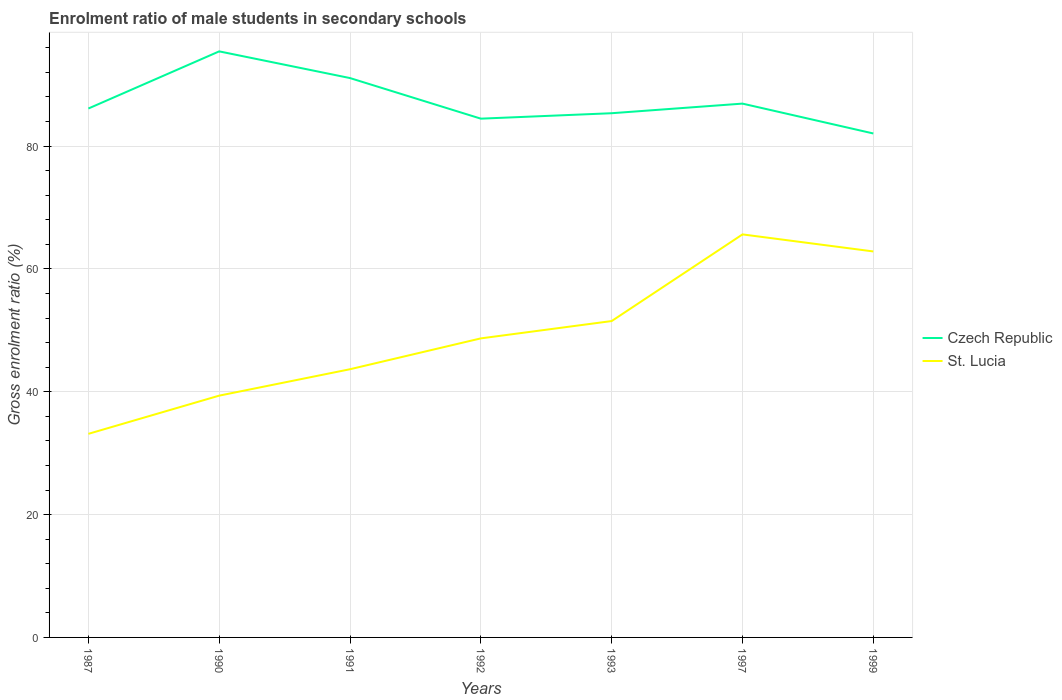How many different coloured lines are there?
Provide a short and direct response. 2. Does the line corresponding to St. Lucia intersect with the line corresponding to Czech Republic?
Provide a succinct answer. No. Across all years, what is the maximum enrolment ratio of male students in secondary schools in St. Lucia?
Provide a succinct answer. 33.15. What is the total enrolment ratio of male students in secondary schools in St. Lucia in the graph?
Give a very brief answer. -2.82. What is the difference between the highest and the second highest enrolment ratio of male students in secondary schools in St. Lucia?
Your answer should be compact. 32.47. Is the enrolment ratio of male students in secondary schools in Czech Republic strictly greater than the enrolment ratio of male students in secondary schools in St. Lucia over the years?
Make the answer very short. No. What is the difference between two consecutive major ticks on the Y-axis?
Provide a short and direct response. 20. Does the graph contain any zero values?
Give a very brief answer. No. Does the graph contain grids?
Keep it short and to the point. Yes. Where does the legend appear in the graph?
Your answer should be compact. Center right. How are the legend labels stacked?
Offer a terse response. Vertical. What is the title of the graph?
Keep it short and to the point. Enrolment ratio of male students in secondary schools. Does "Heavily indebted poor countries" appear as one of the legend labels in the graph?
Offer a terse response. No. What is the Gross enrolment ratio (%) in Czech Republic in 1987?
Keep it short and to the point. 86.12. What is the Gross enrolment ratio (%) of St. Lucia in 1987?
Your response must be concise. 33.15. What is the Gross enrolment ratio (%) of Czech Republic in 1990?
Ensure brevity in your answer.  95.42. What is the Gross enrolment ratio (%) of St. Lucia in 1990?
Offer a terse response. 39.37. What is the Gross enrolment ratio (%) in Czech Republic in 1991?
Provide a short and direct response. 91.08. What is the Gross enrolment ratio (%) of St. Lucia in 1991?
Provide a succinct answer. 43.67. What is the Gross enrolment ratio (%) in Czech Republic in 1992?
Ensure brevity in your answer.  84.47. What is the Gross enrolment ratio (%) in St. Lucia in 1992?
Keep it short and to the point. 48.69. What is the Gross enrolment ratio (%) of Czech Republic in 1993?
Offer a terse response. 85.35. What is the Gross enrolment ratio (%) in St. Lucia in 1993?
Keep it short and to the point. 51.51. What is the Gross enrolment ratio (%) of Czech Republic in 1997?
Offer a terse response. 86.92. What is the Gross enrolment ratio (%) in St. Lucia in 1997?
Offer a very short reply. 65.62. What is the Gross enrolment ratio (%) of Czech Republic in 1999?
Ensure brevity in your answer.  82.05. What is the Gross enrolment ratio (%) of St. Lucia in 1999?
Your answer should be very brief. 62.85. Across all years, what is the maximum Gross enrolment ratio (%) in Czech Republic?
Ensure brevity in your answer.  95.42. Across all years, what is the maximum Gross enrolment ratio (%) in St. Lucia?
Your answer should be compact. 65.62. Across all years, what is the minimum Gross enrolment ratio (%) in Czech Republic?
Provide a short and direct response. 82.05. Across all years, what is the minimum Gross enrolment ratio (%) of St. Lucia?
Provide a succinct answer. 33.15. What is the total Gross enrolment ratio (%) in Czech Republic in the graph?
Your response must be concise. 611.41. What is the total Gross enrolment ratio (%) in St. Lucia in the graph?
Offer a terse response. 344.86. What is the difference between the Gross enrolment ratio (%) in Czech Republic in 1987 and that in 1990?
Ensure brevity in your answer.  -9.31. What is the difference between the Gross enrolment ratio (%) in St. Lucia in 1987 and that in 1990?
Ensure brevity in your answer.  -6.22. What is the difference between the Gross enrolment ratio (%) of Czech Republic in 1987 and that in 1991?
Ensure brevity in your answer.  -4.96. What is the difference between the Gross enrolment ratio (%) in St. Lucia in 1987 and that in 1991?
Your answer should be very brief. -10.52. What is the difference between the Gross enrolment ratio (%) in Czech Republic in 1987 and that in 1992?
Ensure brevity in your answer.  1.65. What is the difference between the Gross enrolment ratio (%) in St. Lucia in 1987 and that in 1992?
Provide a succinct answer. -15.54. What is the difference between the Gross enrolment ratio (%) in Czech Republic in 1987 and that in 1993?
Give a very brief answer. 0.76. What is the difference between the Gross enrolment ratio (%) in St. Lucia in 1987 and that in 1993?
Your answer should be compact. -18.37. What is the difference between the Gross enrolment ratio (%) in Czech Republic in 1987 and that in 1997?
Provide a succinct answer. -0.8. What is the difference between the Gross enrolment ratio (%) in St. Lucia in 1987 and that in 1997?
Ensure brevity in your answer.  -32.47. What is the difference between the Gross enrolment ratio (%) of Czech Republic in 1987 and that in 1999?
Offer a very short reply. 4.06. What is the difference between the Gross enrolment ratio (%) of St. Lucia in 1987 and that in 1999?
Provide a short and direct response. -29.7. What is the difference between the Gross enrolment ratio (%) of Czech Republic in 1990 and that in 1991?
Offer a very short reply. 4.35. What is the difference between the Gross enrolment ratio (%) of St. Lucia in 1990 and that in 1991?
Your answer should be compact. -4.3. What is the difference between the Gross enrolment ratio (%) of Czech Republic in 1990 and that in 1992?
Give a very brief answer. 10.96. What is the difference between the Gross enrolment ratio (%) of St. Lucia in 1990 and that in 1992?
Provide a short and direct response. -9.32. What is the difference between the Gross enrolment ratio (%) in Czech Republic in 1990 and that in 1993?
Your response must be concise. 10.07. What is the difference between the Gross enrolment ratio (%) of St. Lucia in 1990 and that in 1993?
Give a very brief answer. -12.14. What is the difference between the Gross enrolment ratio (%) in Czech Republic in 1990 and that in 1997?
Give a very brief answer. 8.51. What is the difference between the Gross enrolment ratio (%) of St. Lucia in 1990 and that in 1997?
Your answer should be compact. -26.25. What is the difference between the Gross enrolment ratio (%) of Czech Republic in 1990 and that in 1999?
Your answer should be compact. 13.37. What is the difference between the Gross enrolment ratio (%) of St. Lucia in 1990 and that in 1999?
Provide a short and direct response. -23.48. What is the difference between the Gross enrolment ratio (%) in Czech Republic in 1991 and that in 1992?
Offer a terse response. 6.61. What is the difference between the Gross enrolment ratio (%) of St. Lucia in 1991 and that in 1992?
Provide a succinct answer. -5.02. What is the difference between the Gross enrolment ratio (%) of Czech Republic in 1991 and that in 1993?
Provide a short and direct response. 5.72. What is the difference between the Gross enrolment ratio (%) in St. Lucia in 1991 and that in 1993?
Offer a very short reply. -7.84. What is the difference between the Gross enrolment ratio (%) in Czech Republic in 1991 and that in 1997?
Provide a succinct answer. 4.16. What is the difference between the Gross enrolment ratio (%) in St. Lucia in 1991 and that in 1997?
Your answer should be very brief. -21.95. What is the difference between the Gross enrolment ratio (%) in Czech Republic in 1991 and that in 1999?
Your answer should be compact. 9.02. What is the difference between the Gross enrolment ratio (%) of St. Lucia in 1991 and that in 1999?
Your answer should be compact. -19.18. What is the difference between the Gross enrolment ratio (%) in Czech Republic in 1992 and that in 1993?
Your response must be concise. -0.89. What is the difference between the Gross enrolment ratio (%) of St. Lucia in 1992 and that in 1993?
Make the answer very short. -2.82. What is the difference between the Gross enrolment ratio (%) of Czech Republic in 1992 and that in 1997?
Give a very brief answer. -2.45. What is the difference between the Gross enrolment ratio (%) of St. Lucia in 1992 and that in 1997?
Ensure brevity in your answer.  -16.93. What is the difference between the Gross enrolment ratio (%) of Czech Republic in 1992 and that in 1999?
Offer a very short reply. 2.41. What is the difference between the Gross enrolment ratio (%) in St. Lucia in 1992 and that in 1999?
Keep it short and to the point. -14.15. What is the difference between the Gross enrolment ratio (%) in Czech Republic in 1993 and that in 1997?
Offer a very short reply. -1.56. What is the difference between the Gross enrolment ratio (%) in St. Lucia in 1993 and that in 1997?
Your response must be concise. -14.11. What is the difference between the Gross enrolment ratio (%) of Czech Republic in 1993 and that in 1999?
Offer a terse response. 3.3. What is the difference between the Gross enrolment ratio (%) of St. Lucia in 1993 and that in 1999?
Keep it short and to the point. -11.33. What is the difference between the Gross enrolment ratio (%) of Czech Republic in 1997 and that in 1999?
Your answer should be very brief. 4.86. What is the difference between the Gross enrolment ratio (%) in St. Lucia in 1997 and that in 1999?
Your response must be concise. 2.77. What is the difference between the Gross enrolment ratio (%) in Czech Republic in 1987 and the Gross enrolment ratio (%) in St. Lucia in 1990?
Provide a short and direct response. 46.75. What is the difference between the Gross enrolment ratio (%) of Czech Republic in 1987 and the Gross enrolment ratio (%) of St. Lucia in 1991?
Your response must be concise. 42.45. What is the difference between the Gross enrolment ratio (%) in Czech Republic in 1987 and the Gross enrolment ratio (%) in St. Lucia in 1992?
Your answer should be very brief. 37.43. What is the difference between the Gross enrolment ratio (%) in Czech Republic in 1987 and the Gross enrolment ratio (%) in St. Lucia in 1993?
Provide a succinct answer. 34.6. What is the difference between the Gross enrolment ratio (%) of Czech Republic in 1987 and the Gross enrolment ratio (%) of St. Lucia in 1997?
Keep it short and to the point. 20.5. What is the difference between the Gross enrolment ratio (%) in Czech Republic in 1987 and the Gross enrolment ratio (%) in St. Lucia in 1999?
Offer a terse response. 23.27. What is the difference between the Gross enrolment ratio (%) in Czech Republic in 1990 and the Gross enrolment ratio (%) in St. Lucia in 1991?
Ensure brevity in your answer.  51.75. What is the difference between the Gross enrolment ratio (%) of Czech Republic in 1990 and the Gross enrolment ratio (%) of St. Lucia in 1992?
Offer a very short reply. 46.73. What is the difference between the Gross enrolment ratio (%) in Czech Republic in 1990 and the Gross enrolment ratio (%) in St. Lucia in 1993?
Make the answer very short. 43.91. What is the difference between the Gross enrolment ratio (%) in Czech Republic in 1990 and the Gross enrolment ratio (%) in St. Lucia in 1997?
Your response must be concise. 29.8. What is the difference between the Gross enrolment ratio (%) in Czech Republic in 1990 and the Gross enrolment ratio (%) in St. Lucia in 1999?
Offer a terse response. 32.58. What is the difference between the Gross enrolment ratio (%) of Czech Republic in 1991 and the Gross enrolment ratio (%) of St. Lucia in 1992?
Ensure brevity in your answer.  42.38. What is the difference between the Gross enrolment ratio (%) of Czech Republic in 1991 and the Gross enrolment ratio (%) of St. Lucia in 1993?
Provide a succinct answer. 39.56. What is the difference between the Gross enrolment ratio (%) of Czech Republic in 1991 and the Gross enrolment ratio (%) of St. Lucia in 1997?
Give a very brief answer. 25.45. What is the difference between the Gross enrolment ratio (%) of Czech Republic in 1991 and the Gross enrolment ratio (%) of St. Lucia in 1999?
Your answer should be very brief. 28.23. What is the difference between the Gross enrolment ratio (%) of Czech Republic in 1992 and the Gross enrolment ratio (%) of St. Lucia in 1993?
Offer a terse response. 32.95. What is the difference between the Gross enrolment ratio (%) in Czech Republic in 1992 and the Gross enrolment ratio (%) in St. Lucia in 1997?
Your answer should be compact. 18.85. What is the difference between the Gross enrolment ratio (%) of Czech Republic in 1992 and the Gross enrolment ratio (%) of St. Lucia in 1999?
Provide a short and direct response. 21.62. What is the difference between the Gross enrolment ratio (%) of Czech Republic in 1993 and the Gross enrolment ratio (%) of St. Lucia in 1997?
Your answer should be very brief. 19.73. What is the difference between the Gross enrolment ratio (%) in Czech Republic in 1993 and the Gross enrolment ratio (%) in St. Lucia in 1999?
Your response must be concise. 22.51. What is the difference between the Gross enrolment ratio (%) of Czech Republic in 1997 and the Gross enrolment ratio (%) of St. Lucia in 1999?
Keep it short and to the point. 24.07. What is the average Gross enrolment ratio (%) in Czech Republic per year?
Provide a succinct answer. 87.34. What is the average Gross enrolment ratio (%) in St. Lucia per year?
Offer a very short reply. 49.27. In the year 1987, what is the difference between the Gross enrolment ratio (%) in Czech Republic and Gross enrolment ratio (%) in St. Lucia?
Ensure brevity in your answer.  52.97. In the year 1990, what is the difference between the Gross enrolment ratio (%) of Czech Republic and Gross enrolment ratio (%) of St. Lucia?
Provide a succinct answer. 56.05. In the year 1991, what is the difference between the Gross enrolment ratio (%) in Czech Republic and Gross enrolment ratio (%) in St. Lucia?
Your answer should be very brief. 47.41. In the year 1992, what is the difference between the Gross enrolment ratio (%) in Czech Republic and Gross enrolment ratio (%) in St. Lucia?
Provide a short and direct response. 35.77. In the year 1993, what is the difference between the Gross enrolment ratio (%) in Czech Republic and Gross enrolment ratio (%) in St. Lucia?
Give a very brief answer. 33.84. In the year 1997, what is the difference between the Gross enrolment ratio (%) in Czech Republic and Gross enrolment ratio (%) in St. Lucia?
Provide a short and direct response. 21.3. In the year 1999, what is the difference between the Gross enrolment ratio (%) of Czech Republic and Gross enrolment ratio (%) of St. Lucia?
Ensure brevity in your answer.  19.21. What is the ratio of the Gross enrolment ratio (%) in Czech Republic in 1987 to that in 1990?
Your response must be concise. 0.9. What is the ratio of the Gross enrolment ratio (%) in St. Lucia in 1987 to that in 1990?
Your answer should be compact. 0.84. What is the ratio of the Gross enrolment ratio (%) of Czech Republic in 1987 to that in 1991?
Offer a very short reply. 0.95. What is the ratio of the Gross enrolment ratio (%) in St. Lucia in 1987 to that in 1991?
Give a very brief answer. 0.76. What is the ratio of the Gross enrolment ratio (%) in Czech Republic in 1987 to that in 1992?
Ensure brevity in your answer.  1.02. What is the ratio of the Gross enrolment ratio (%) of St. Lucia in 1987 to that in 1992?
Ensure brevity in your answer.  0.68. What is the ratio of the Gross enrolment ratio (%) in Czech Republic in 1987 to that in 1993?
Make the answer very short. 1.01. What is the ratio of the Gross enrolment ratio (%) of St. Lucia in 1987 to that in 1993?
Offer a very short reply. 0.64. What is the ratio of the Gross enrolment ratio (%) in St. Lucia in 1987 to that in 1997?
Keep it short and to the point. 0.51. What is the ratio of the Gross enrolment ratio (%) of Czech Republic in 1987 to that in 1999?
Offer a terse response. 1.05. What is the ratio of the Gross enrolment ratio (%) in St. Lucia in 1987 to that in 1999?
Make the answer very short. 0.53. What is the ratio of the Gross enrolment ratio (%) of Czech Republic in 1990 to that in 1991?
Give a very brief answer. 1.05. What is the ratio of the Gross enrolment ratio (%) in St. Lucia in 1990 to that in 1991?
Give a very brief answer. 0.9. What is the ratio of the Gross enrolment ratio (%) of Czech Republic in 1990 to that in 1992?
Make the answer very short. 1.13. What is the ratio of the Gross enrolment ratio (%) in St. Lucia in 1990 to that in 1992?
Keep it short and to the point. 0.81. What is the ratio of the Gross enrolment ratio (%) of Czech Republic in 1990 to that in 1993?
Make the answer very short. 1.12. What is the ratio of the Gross enrolment ratio (%) in St. Lucia in 1990 to that in 1993?
Offer a terse response. 0.76. What is the ratio of the Gross enrolment ratio (%) of Czech Republic in 1990 to that in 1997?
Your response must be concise. 1.1. What is the ratio of the Gross enrolment ratio (%) in St. Lucia in 1990 to that in 1997?
Offer a terse response. 0.6. What is the ratio of the Gross enrolment ratio (%) in Czech Republic in 1990 to that in 1999?
Your answer should be compact. 1.16. What is the ratio of the Gross enrolment ratio (%) in St. Lucia in 1990 to that in 1999?
Provide a succinct answer. 0.63. What is the ratio of the Gross enrolment ratio (%) in Czech Republic in 1991 to that in 1992?
Provide a succinct answer. 1.08. What is the ratio of the Gross enrolment ratio (%) of St. Lucia in 1991 to that in 1992?
Keep it short and to the point. 0.9. What is the ratio of the Gross enrolment ratio (%) of Czech Republic in 1991 to that in 1993?
Give a very brief answer. 1.07. What is the ratio of the Gross enrolment ratio (%) of St. Lucia in 1991 to that in 1993?
Your response must be concise. 0.85. What is the ratio of the Gross enrolment ratio (%) in Czech Republic in 1991 to that in 1997?
Your answer should be compact. 1.05. What is the ratio of the Gross enrolment ratio (%) in St. Lucia in 1991 to that in 1997?
Give a very brief answer. 0.67. What is the ratio of the Gross enrolment ratio (%) of Czech Republic in 1991 to that in 1999?
Provide a short and direct response. 1.11. What is the ratio of the Gross enrolment ratio (%) in St. Lucia in 1991 to that in 1999?
Your response must be concise. 0.69. What is the ratio of the Gross enrolment ratio (%) in St. Lucia in 1992 to that in 1993?
Offer a terse response. 0.95. What is the ratio of the Gross enrolment ratio (%) of Czech Republic in 1992 to that in 1997?
Your answer should be compact. 0.97. What is the ratio of the Gross enrolment ratio (%) of St. Lucia in 1992 to that in 1997?
Provide a short and direct response. 0.74. What is the ratio of the Gross enrolment ratio (%) in Czech Republic in 1992 to that in 1999?
Offer a terse response. 1.03. What is the ratio of the Gross enrolment ratio (%) of St. Lucia in 1992 to that in 1999?
Offer a terse response. 0.77. What is the ratio of the Gross enrolment ratio (%) of Czech Republic in 1993 to that in 1997?
Provide a short and direct response. 0.98. What is the ratio of the Gross enrolment ratio (%) in St. Lucia in 1993 to that in 1997?
Offer a very short reply. 0.79. What is the ratio of the Gross enrolment ratio (%) of Czech Republic in 1993 to that in 1999?
Your response must be concise. 1.04. What is the ratio of the Gross enrolment ratio (%) of St. Lucia in 1993 to that in 1999?
Keep it short and to the point. 0.82. What is the ratio of the Gross enrolment ratio (%) in Czech Republic in 1997 to that in 1999?
Your answer should be very brief. 1.06. What is the ratio of the Gross enrolment ratio (%) in St. Lucia in 1997 to that in 1999?
Ensure brevity in your answer.  1.04. What is the difference between the highest and the second highest Gross enrolment ratio (%) in Czech Republic?
Ensure brevity in your answer.  4.35. What is the difference between the highest and the second highest Gross enrolment ratio (%) of St. Lucia?
Make the answer very short. 2.77. What is the difference between the highest and the lowest Gross enrolment ratio (%) of Czech Republic?
Ensure brevity in your answer.  13.37. What is the difference between the highest and the lowest Gross enrolment ratio (%) of St. Lucia?
Give a very brief answer. 32.47. 